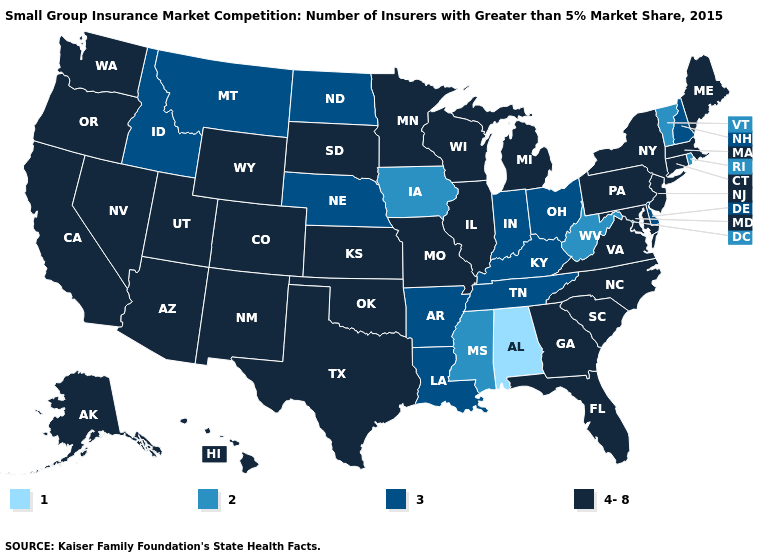Name the states that have a value in the range 1?
Be succinct. Alabama. What is the value of Wyoming?
Short answer required. 4-8. What is the lowest value in states that border Tennessee?
Quick response, please. 1. What is the value of Alaska?
Give a very brief answer. 4-8. Name the states that have a value in the range 3?
Answer briefly. Arkansas, Delaware, Idaho, Indiana, Kentucky, Louisiana, Montana, Nebraska, New Hampshire, North Dakota, Ohio, Tennessee. What is the value of Tennessee?
Answer briefly. 3. Does Arkansas have a higher value than New York?
Short answer required. No. Name the states that have a value in the range 4-8?
Answer briefly. Alaska, Arizona, California, Colorado, Connecticut, Florida, Georgia, Hawaii, Illinois, Kansas, Maine, Maryland, Massachusetts, Michigan, Minnesota, Missouri, Nevada, New Jersey, New Mexico, New York, North Carolina, Oklahoma, Oregon, Pennsylvania, South Carolina, South Dakota, Texas, Utah, Virginia, Washington, Wisconsin, Wyoming. Name the states that have a value in the range 2?
Keep it brief. Iowa, Mississippi, Rhode Island, Vermont, West Virginia. Does the map have missing data?
Answer briefly. No. What is the value of Wisconsin?
Concise answer only. 4-8. What is the lowest value in the USA?
Keep it brief. 1. Does Utah have the same value as Wisconsin?
Be succinct. Yes. What is the value of North Dakota?
Short answer required. 3. Name the states that have a value in the range 2?
Keep it brief. Iowa, Mississippi, Rhode Island, Vermont, West Virginia. 